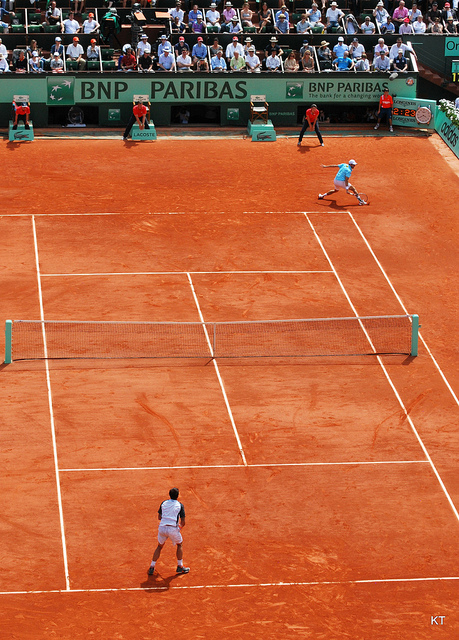Extract all visible text content from this image. BNP PARIBAS KT BNP PARIBAS 2:23 Changing a bank The 